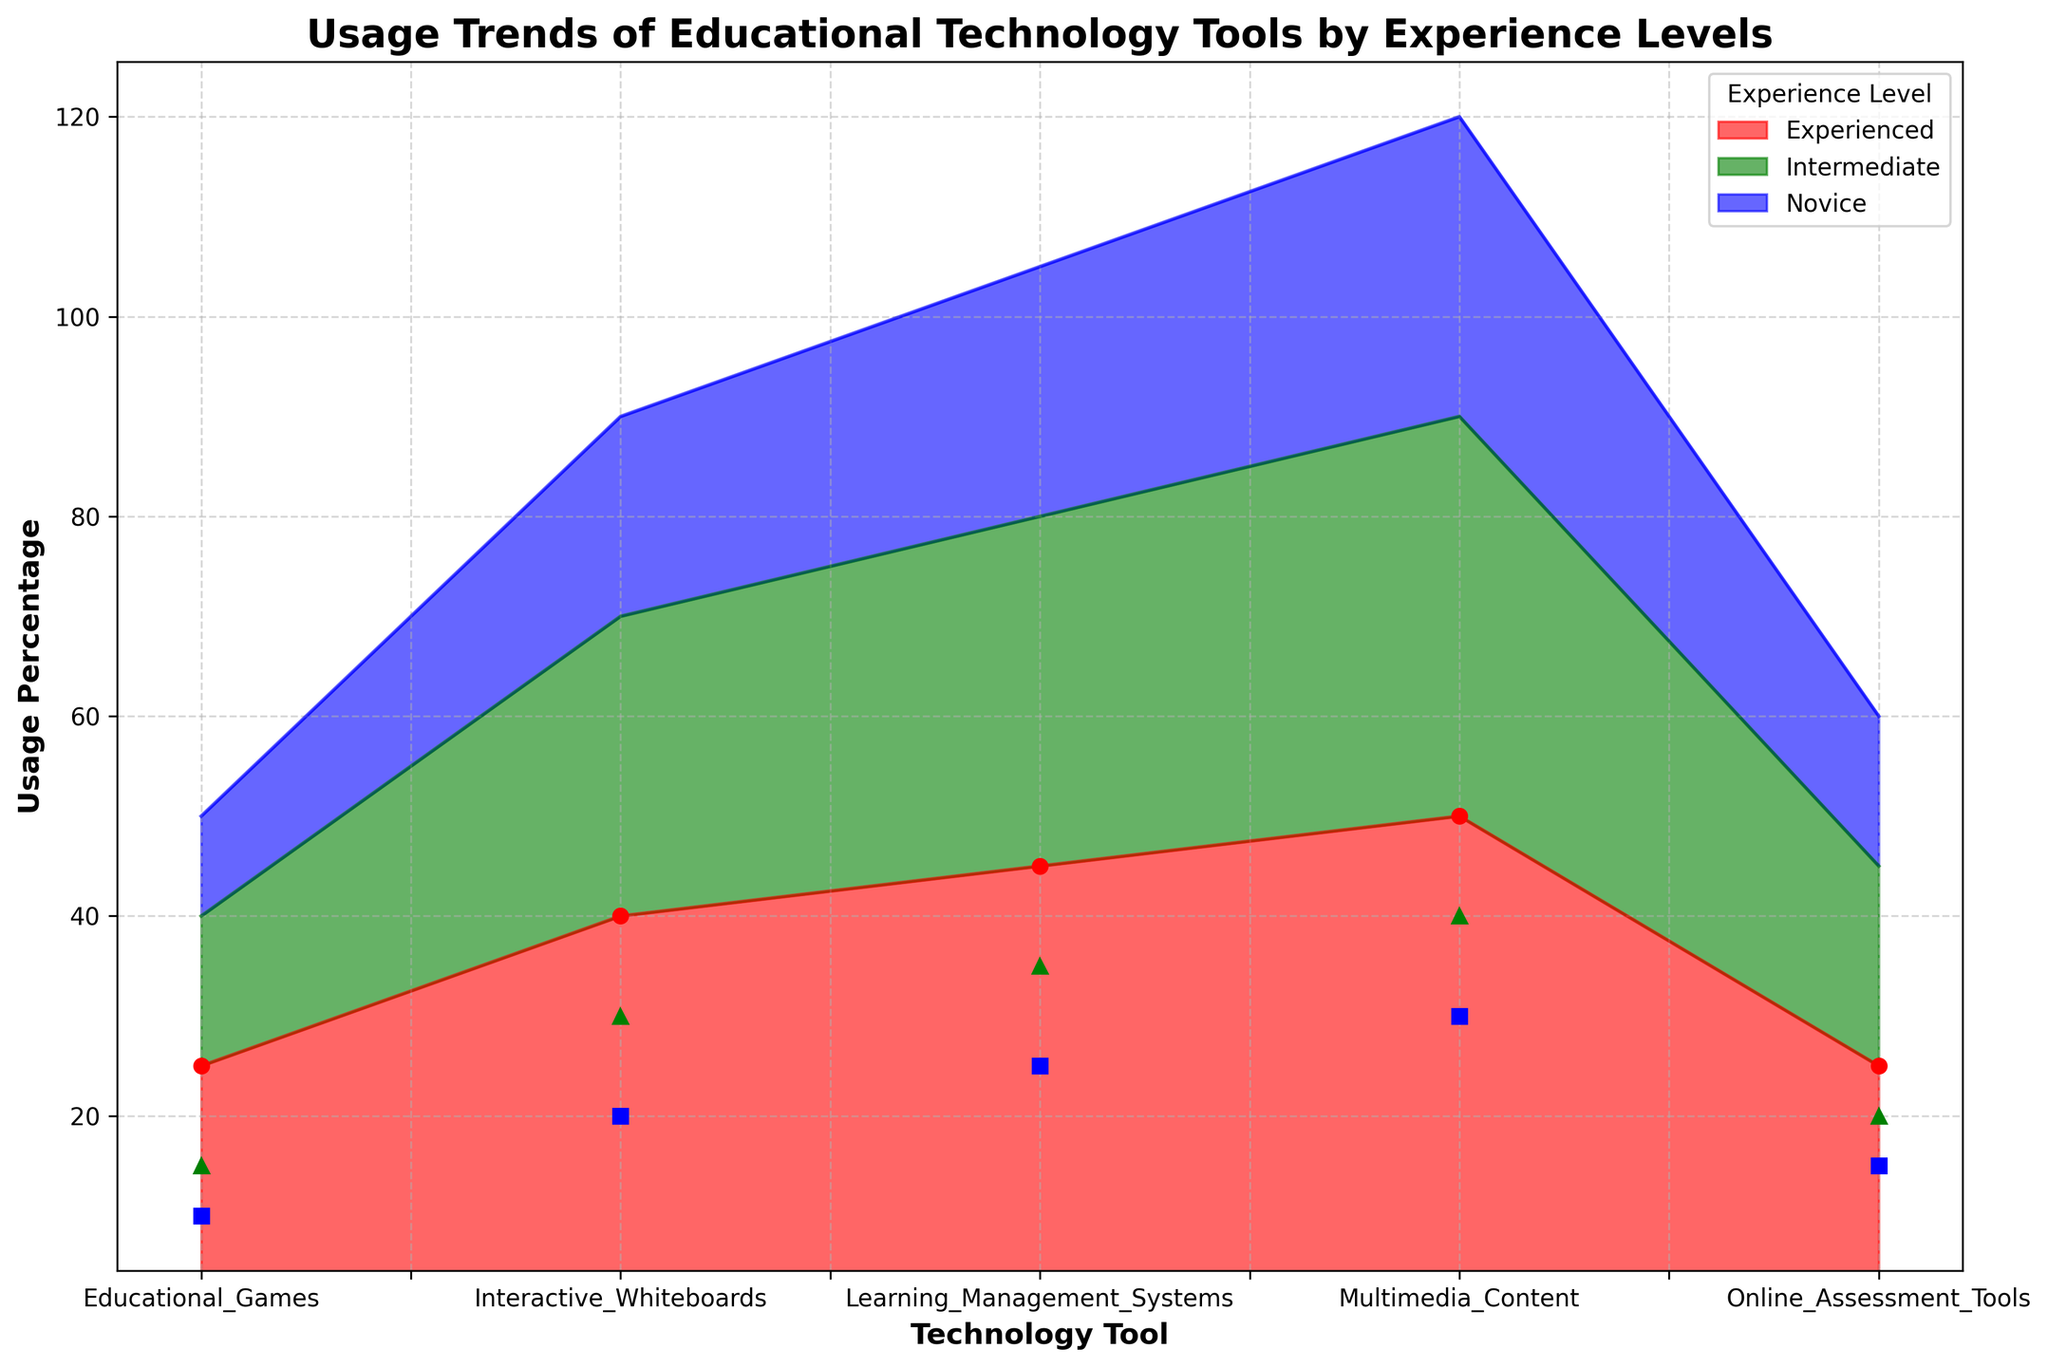What is the total usage percentage of Interactive Whiteboards by all experience levels combined? To find the total, sum the usage percentages of Interactive Whiteboards for Novice (20%), Intermediate (30%), and Experienced (40%). Therefore, 20 + 30 + 40 = 90.
Answer: 90 Which experience level shows the highest usage of Multimedia Content? Compare the usage percentages of Multimedia Content among Novice (30%), Intermediate (40%), and Experienced (50%). The highest usage is by the Experienced group (50%).
Answer: Experienced How does the usage percentage of Educational Games differ between Novice and Experienced teachers? Subtract the usage percentage by Novice teachers (10%) from the usage percentage by Experienced teachers (25%), resulting in 25 - 10 = 15.
Answer: 15 Which technology tool has the highest impact quality score among Intermediate teachers? The impact quality scores for Intermediate teachers are: Interactive Whiteboards (3.5), Learning Management Systems (4.2), Online Assessment Tools (3.7), Educational Games (3.3), and Multimedia Content (4.0). The highest score is for Learning Management Systems (4.2).
Answer: Learning Management Systems What is the average impact quality score of Learning Management Systems across all experience levels? Add the impact quality scores for Learning Management Systems: Novice (4.0), Intermediate (4.2), and Experienced (4.5), then divide by 3. Therefore, (4.0 + 4.2 + 4.5) / 3 ≈ 4.23.
Answer: 4.23 Which experience level contributes the most to the total usage percentage of Educational Games? The usage percentages for Educational Games are: Novice (10%), Intermediate (15%), and Experienced (25%). The highest contribution is from the Experienced teachers (25%).
Answer: Experienced Comparing Online Assessment Tools, by how much does the impact quality score differ between Novice and Experienced teachers? Subtract the impact quality score for Novice teachers (3.5) from the score for Experienced teachers (3.9), resulting in 3.9 - 3.5 = 0.4.
Answer: 0.4 Which technology tool had the greatest variation in usage percentage across all experience levels? Calculate the variation (range) for each tool:
- Interactive Whiteboards: 40 - 20 = 20
- Learning Management Systems: 45 - 25 = 20
- Online Assessment Tools: 25 - 15 = 10
- Educational Games: 25 - 10 = 15
- Multimedia Content: 50 - 30 = 20
The highest variation is observed in Interactive Whiteboards, Learning Management Systems, and Multimedia Content (20).
Answer: Interactive Whiteboards, Learning Management Systems, Multimedia Content 